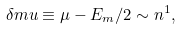Convert formula to latex. <formula><loc_0><loc_0><loc_500><loc_500>\delta m u \equiv \mu - E _ { m } / 2 \sim n ^ { 1 } ,</formula> 